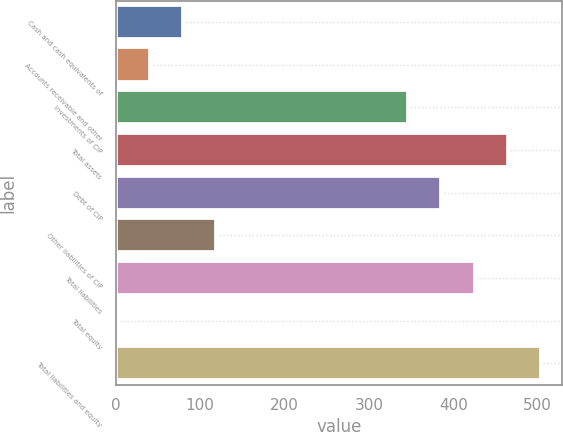Convert chart to OTSL. <chart><loc_0><loc_0><loc_500><loc_500><bar_chart><fcel>Cash and cash equivalents of<fcel>Accounts receivable and other<fcel>Investments of CIP<fcel>Total assets<fcel>Debt of CIP<fcel>Other liabilities of CIP<fcel>Total liabilities<fcel>Total equity<fcel>Total liabilities and equity<nl><fcel>79.72<fcel>40.36<fcel>346.5<fcel>464.58<fcel>385.86<fcel>119.08<fcel>425.22<fcel>1<fcel>503.94<nl></chart> 